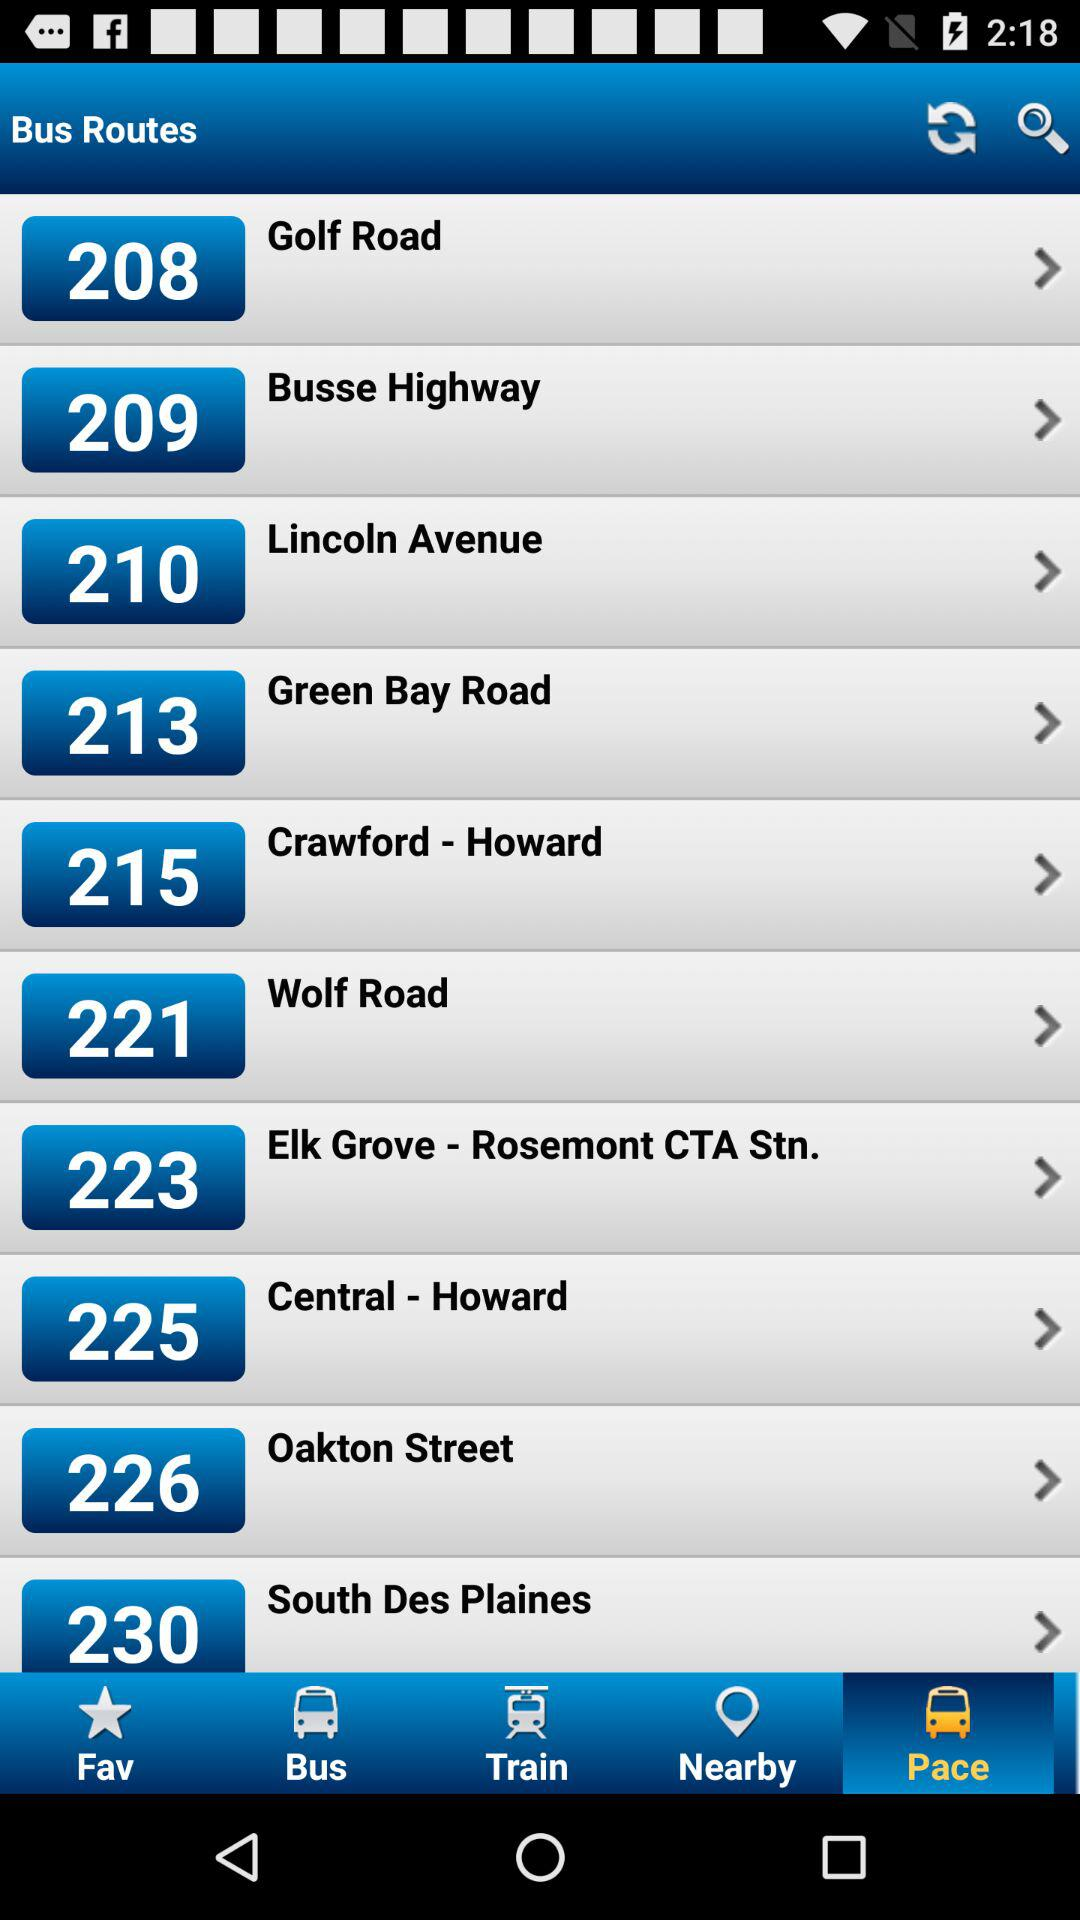Which tab is selected? The selected tab is "Pace". 